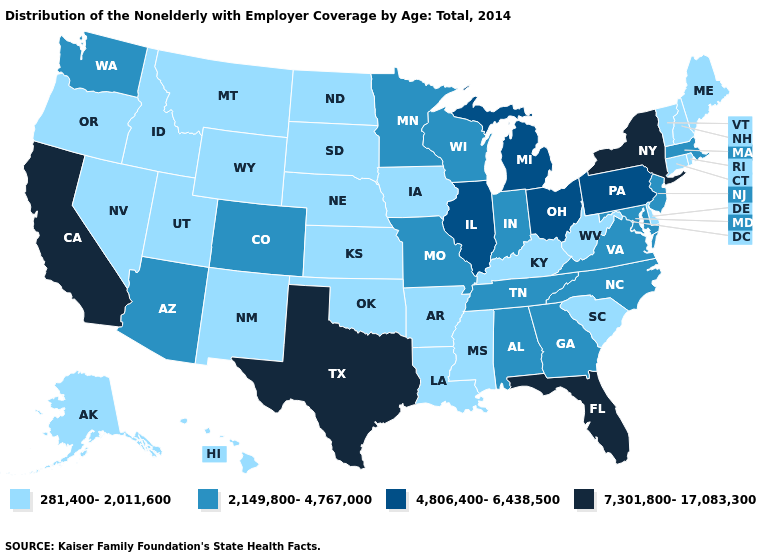Does Arizona have the highest value in the West?
Write a very short answer. No. Which states have the highest value in the USA?
Give a very brief answer. California, Florida, New York, Texas. Among the states that border Virginia , which have the lowest value?
Quick response, please. Kentucky, West Virginia. Name the states that have a value in the range 4,806,400-6,438,500?
Keep it brief. Illinois, Michigan, Ohio, Pennsylvania. Among the states that border Ohio , which have the lowest value?
Be succinct. Kentucky, West Virginia. What is the value of Tennessee?
Be succinct. 2,149,800-4,767,000. What is the highest value in the South ?
Be succinct. 7,301,800-17,083,300. What is the value of Ohio?
Write a very short answer. 4,806,400-6,438,500. Name the states that have a value in the range 4,806,400-6,438,500?
Answer briefly. Illinois, Michigan, Ohio, Pennsylvania. Name the states that have a value in the range 281,400-2,011,600?
Quick response, please. Alaska, Arkansas, Connecticut, Delaware, Hawaii, Idaho, Iowa, Kansas, Kentucky, Louisiana, Maine, Mississippi, Montana, Nebraska, Nevada, New Hampshire, New Mexico, North Dakota, Oklahoma, Oregon, Rhode Island, South Carolina, South Dakota, Utah, Vermont, West Virginia, Wyoming. Name the states that have a value in the range 4,806,400-6,438,500?
Quick response, please. Illinois, Michigan, Ohio, Pennsylvania. Does Delaware have the highest value in the USA?
Concise answer only. No. Among the states that border Michigan , which have the lowest value?
Write a very short answer. Indiana, Wisconsin. What is the value of Wisconsin?
Short answer required. 2,149,800-4,767,000. Which states have the lowest value in the MidWest?
Be succinct. Iowa, Kansas, Nebraska, North Dakota, South Dakota. 